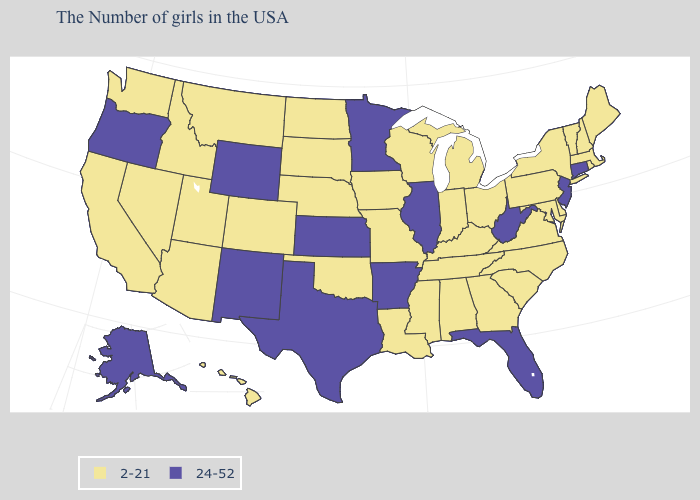What is the lowest value in the West?
Concise answer only. 2-21. Name the states that have a value in the range 2-21?
Be succinct. Maine, Massachusetts, Rhode Island, New Hampshire, Vermont, New York, Delaware, Maryland, Pennsylvania, Virginia, North Carolina, South Carolina, Ohio, Georgia, Michigan, Kentucky, Indiana, Alabama, Tennessee, Wisconsin, Mississippi, Louisiana, Missouri, Iowa, Nebraska, Oklahoma, South Dakota, North Dakota, Colorado, Utah, Montana, Arizona, Idaho, Nevada, California, Washington, Hawaii. Which states have the highest value in the USA?
Answer briefly. Connecticut, New Jersey, West Virginia, Florida, Illinois, Arkansas, Minnesota, Kansas, Texas, Wyoming, New Mexico, Oregon, Alaska. Name the states that have a value in the range 2-21?
Keep it brief. Maine, Massachusetts, Rhode Island, New Hampshire, Vermont, New York, Delaware, Maryland, Pennsylvania, Virginia, North Carolina, South Carolina, Ohio, Georgia, Michigan, Kentucky, Indiana, Alabama, Tennessee, Wisconsin, Mississippi, Louisiana, Missouri, Iowa, Nebraska, Oklahoma, South Dakota, North Dakota, Colorado, Utah, Montana, Arizona, Idaho, Nevada, California, Washington, Hawaii. Is the legend a continuous bar?
Give a very brief answer. No. Name the states that have a value in the range 24-52?
Write a very short answer. Connecticut, New Jersey, West Virginia, Florida, Illinois, Arkansas, Minnesota, Kansas, Texas, Wyoming, New Mexico, Oregon, Alaska. How many symbols are there in the legend?
Answer briefly. 2. Does the first symbol in the legend represent the smallest category?
Keep it brief. Yes. What is the value of Rhode Island?
Be succinct. 2-21. Name the states that have a value in the range 2-21?
Write a very short answer. Maine, Massachusetts, Rhode Island, New Hampshire, Vermont, New York, Delaware, Maryland, Pennsylvania, Virginia, North Carolina, South Carolina, Ohio, Georgia, Michigan, Kentucky, Indiana, Alabama, Tennessee, Wisconsin, Mississippi, Louisiana, Missouri, Iowa, Nebraska, Oklahoma, South Dakota, North Dakota, Colorado, Utah, Montana, Arizona, Idaho, Nevada, California, Washington, Hawaii. Name the states that have a value in the range 2-21?
Write a very short answer. Maine, Massachusetts, Rhode Island, New Hampshire, Vermont, New York, Delaware, Maryland, Pennsylvania, Virginia, North Carolina, South Carolina, Ohio, Georgia, Michigan, Kentucky, Indiana, Alabama, Tennessee, Wisconsin, Mississippi, Louisiana, Missouri, Iowa, Nebraska, Oklahoma, South Dakota, North Dakota, Colorado, Utah, Montana, Arizona, Idaho, Nevada, California, Washington, Hawaii. Name the states that have a value in the range 24-52?
Short answer required. Connecticut, New Jersey, West Virginia, Florida, Illinois, Arkansas, Minnesota, Kansas, Texas, Wyoming, New Mexico, Oregon, Alaska. What is the highest value in the USA?
Keep it brief. 24-52. How many symbols are there in the legend?
Give a very brief answer. 2. Name the states that have a value in the range 24-52?
Give a very brief answer. Connecticut, New Jersey, West Virginia, Florida, Illinois, Arkansas, Minnesota, Kansas, Texas, Wyoming, New Mexico, Oregon, Alaska. 